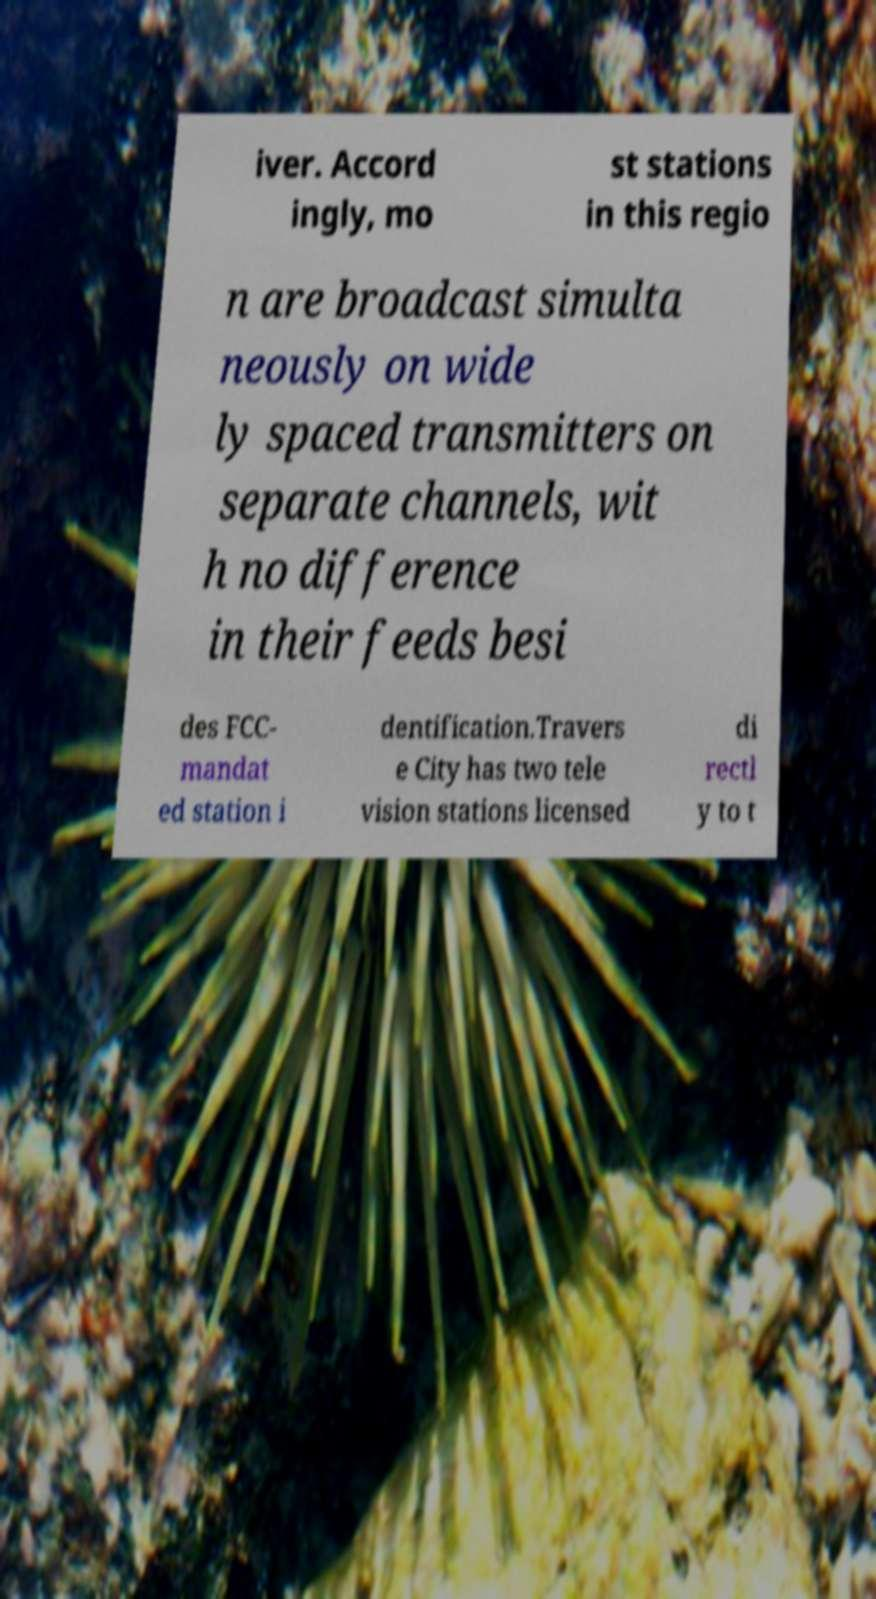I need the written content from this picture converted into text. Can you do that? iver. Accord ingly, mo st stations in this regio n are broadcast simulta neously on wide ly spaced transmitters on separate channels, wit h no difference in their feeds besi des FCC- mandat ed station i dentification.Travers e City has two tele vision stations licensed di rectl y to t 